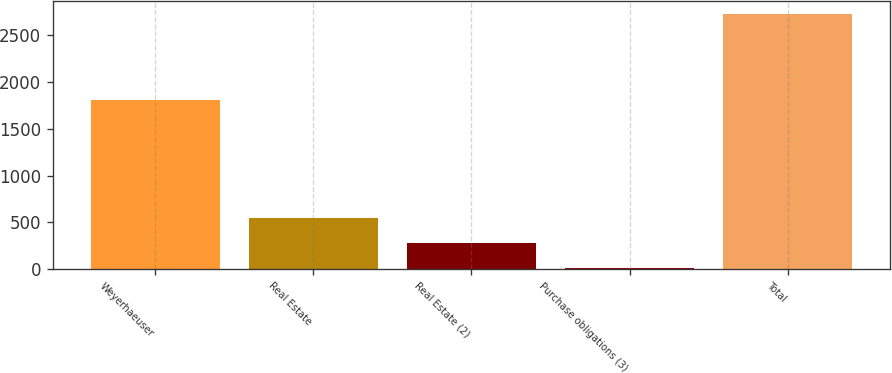Convert chart. <chart><loc_0><loc_0><loc_500><loc_500><bar_chart><fcel>Weyerhaeuser<fcel>Real Estate<fcel>Real Estate (2)<fcel>Purchase obligations (3)<fcel>Total<nl><fcel>1808<fcel>551<fcel>279<fcel>7<fcel>2727<nl></chart> 